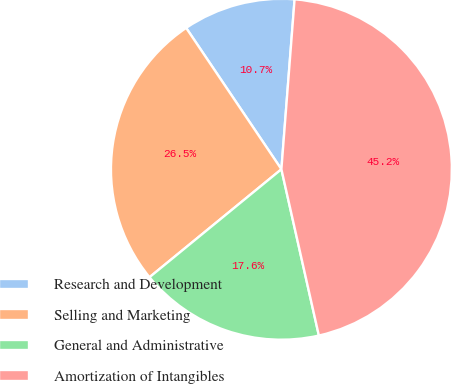Convert chart. <chart><loc_0><loc_0><loc_500><loc_500><pie_chart><fcel>Research and Development<fcel>Selling and Marketing<fcel>General and Administrative<fcel>Amortization of Intangibles<nl><fcel>10.67%<fcel>26.48%<fcel>17.61%<fcel>45.24%<nl></chart> 